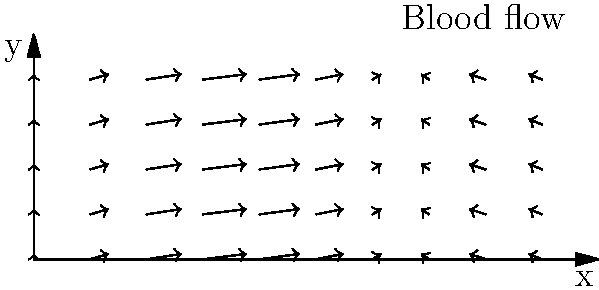In the vector field representation of blood flow in a heart chamber shown above, what does the direction of the arrows primarily indicate about the flow pattern? To analyze the vector field representation of blood flow in a heart chamber:

1. Observe the overall pattern of the arrows in the vector field.
2. Note that the arrows represent the velocity and direction of blood flow at each point.
3. The horizontal component (x-axis) shows variations in flow speed and direction along the chamber.
4. The vertical component (y-axis) indicates the upward movement of blood.
5. The arrows show a repeating pattern along the x-axis, suggesting a wave-like flow.
6. The arrows are consistently pointing upward and to the right, indicating:
   a) An overall forward movement of blood through the chamber.
   b) A simultaneous upward motion, possibly due to the contraction of heart muscles.
7. The varying lengths of the arrows suggest changes in flow velocity at different points.
8. The sinusoidal pattern implies that the blood flow is not uniform but has areas of acceleration and deceleration.

Given these observations, the primary indication from the direction of the arrows is a forward and upward blood flow pattern, characteristic of the blood's movement through a heart chamber during contraction.
Answer: Forward and upward blood flow during heart contraction 